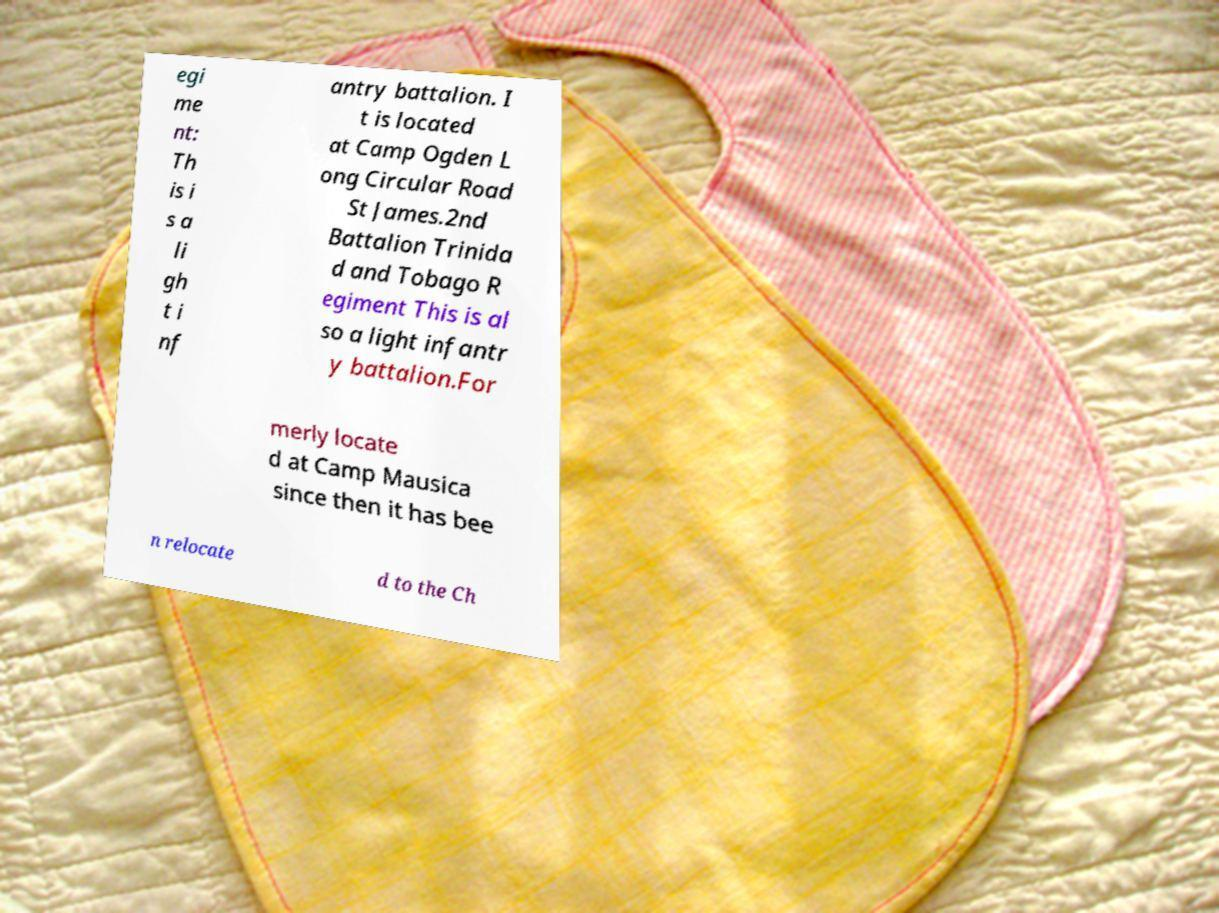Please identify and transcribe the text found in this image. egi me nt: Th is i s a li gh t i nf antry battalion. I t is located at Camp Ogden L ong Circular Road St James.2nd Battalion Trinida d and Tobago R egiment This is al so a light infantr y battalion.For merly locate d at Camp Mausica since then it has bee n relocate d to the Ch 